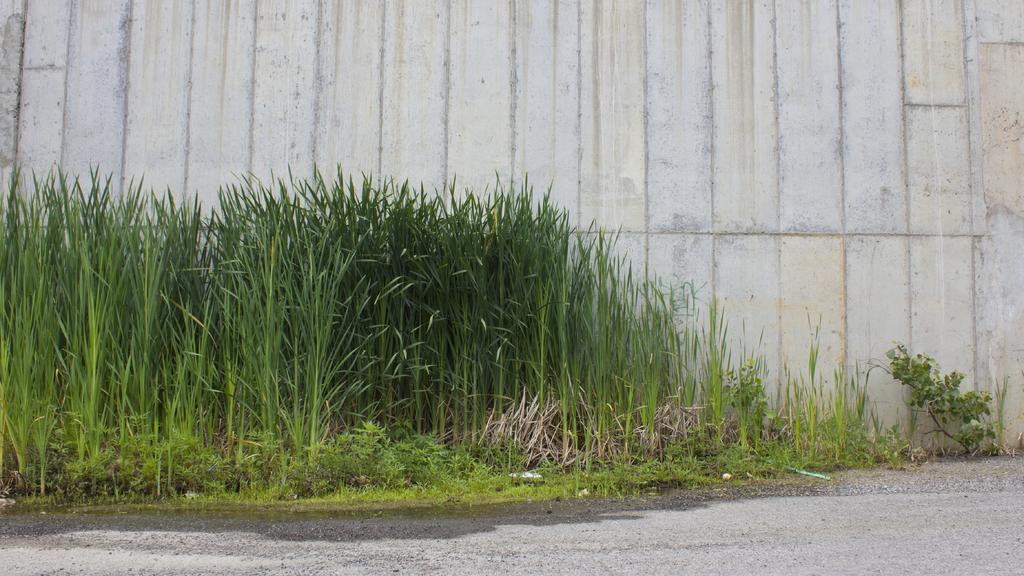Can you describe this image briefly? In this image I can see plants. There is a wall at the back. 